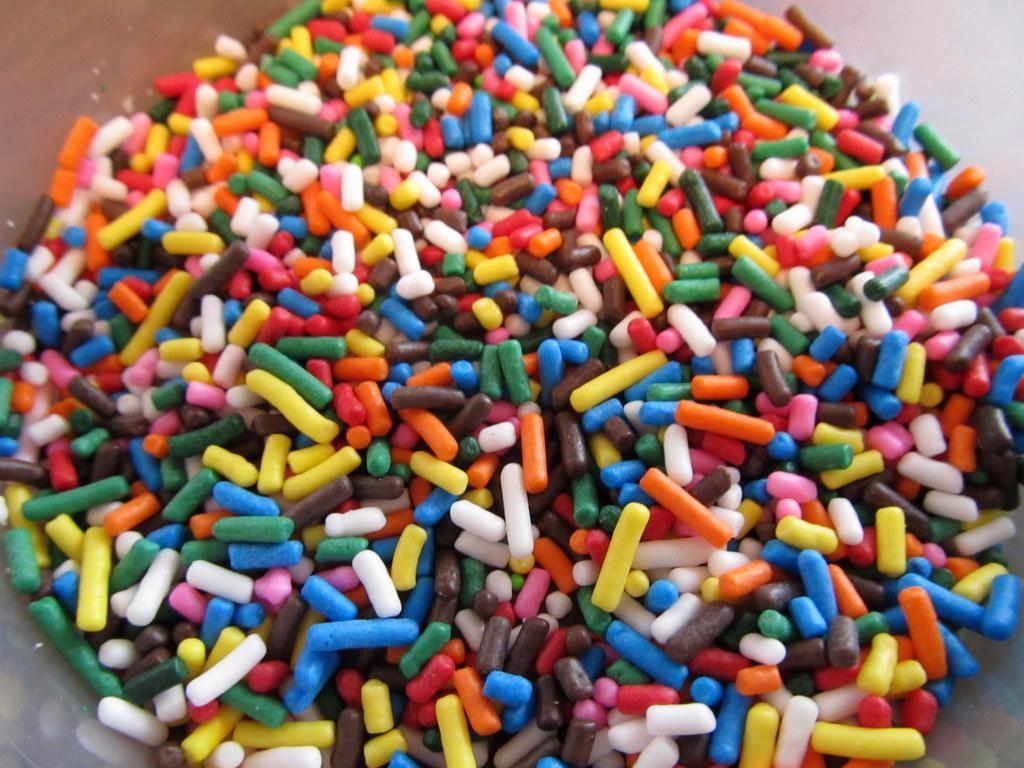Could you give a brief overview of what you see in this image? This picture consists of comfits which are in different color are placed on the brown table. 